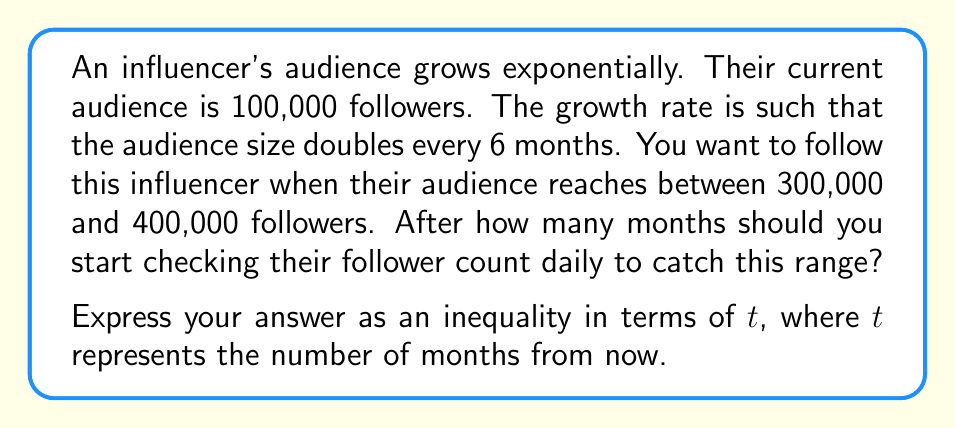Provide a solution to this math problem. Let's approach this step-by-step:

1) First, we need to set up the exponential growth equation. The general form is:

   $A(t) = A_0 \cdot (1+r)^t$

   Where $A(t)$ is the audience size after $t$ months, $A_0$ is the initial audience size, and $(1+r)$ is the growth factor per month.

2) We know that $A_0 = 100,000$ and the audience doubles every 6 months. Let's find $r$:

   $2 = (1+r)^6$
   $\sqrt[6]{2} = 1+r$
   $r = \sqrt[6]{2} - 1 \approx 0.1225$

3) Now our equation is:

   $A(t) = 100,000 \cdot (1.1225)^t$

4) We want to find when this is between 300,000 and 400,000:

   $300,000 < 100,000 \cdot (1.1225)^t < 400,000$

5) Divide everything by 100,000:

   $3 < (1.1225)^t < 4$

6) Take the logarithm of each part (log is increasing, so inequalities remain the same):

   $\log 3 < t \log 1.1225 < \log 4$

7) Divide by $\log 1.1225$ (it's positive, so inequalities remain the same):

   $\frac{\log 3}{\log 1.1225} < t < \frac{\log 4}{\log 1.1225}$

8) Calculate these values:

   $9.03 < t < 11.54$

9) Since $t$ represents months and must be an integer, we can conclude:

   $10 \leq t \leq 11$

This means you should start checking daily after 10 months, but before 12 months have passed.
Answer: $10 \leq t \leq 11$, where $t$ is the number of months from now. 